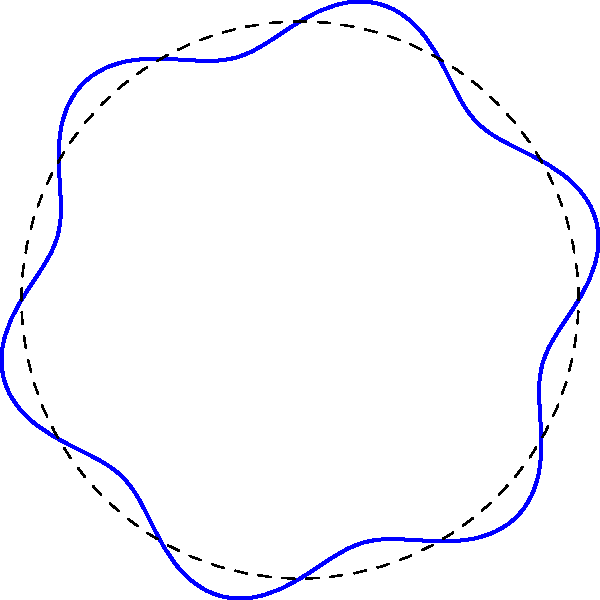As an illustrator designing a comic book panel border with wavy edges, you decide to use a polar function. The general form of your function is $r(\theta) = a + b \sin(c\theta)$, where $a$ represents the average radius, $b$ the amplitude of the waves, and $c$ the frequency. If you want 6 complete waves around the border and the waves to have an amplitude that is 10% of the average radius, what should be the values of $b$ and $c$ in terms of $a$? Let's approach this step-by-step:

1) The general form given is $r(\theta) = a + b \sin(c\theta)$

2) For the frequency:
   - We want 6 complete waves around the border
   - One complete revolution is $2\pi$ radians
   - For 6 waves, we need $c\theta$ to complete 6 cycles when $\theta$ goes from 0 to $2\pi$
   - This means: $c(2\pi) = 6(2\pi)$
   - Solving for $c$: $c = 6$

3) For the amplitude:
   - The amplitude is represented by $b$
   - We're told it should be 10% of the average radius $a$
   - This means: $b = 0.1a$

4) Therefore, our final function would be:
   $r(\theta) = a + 0.1a \sin(6\theta)$

5) Comparing to the original form $r(\theta) = a + b \sin(c\theta)$:
   $b = 0.1a$ and $c = 6$
Answer: $b = 0.1a$, $c = 6$ 